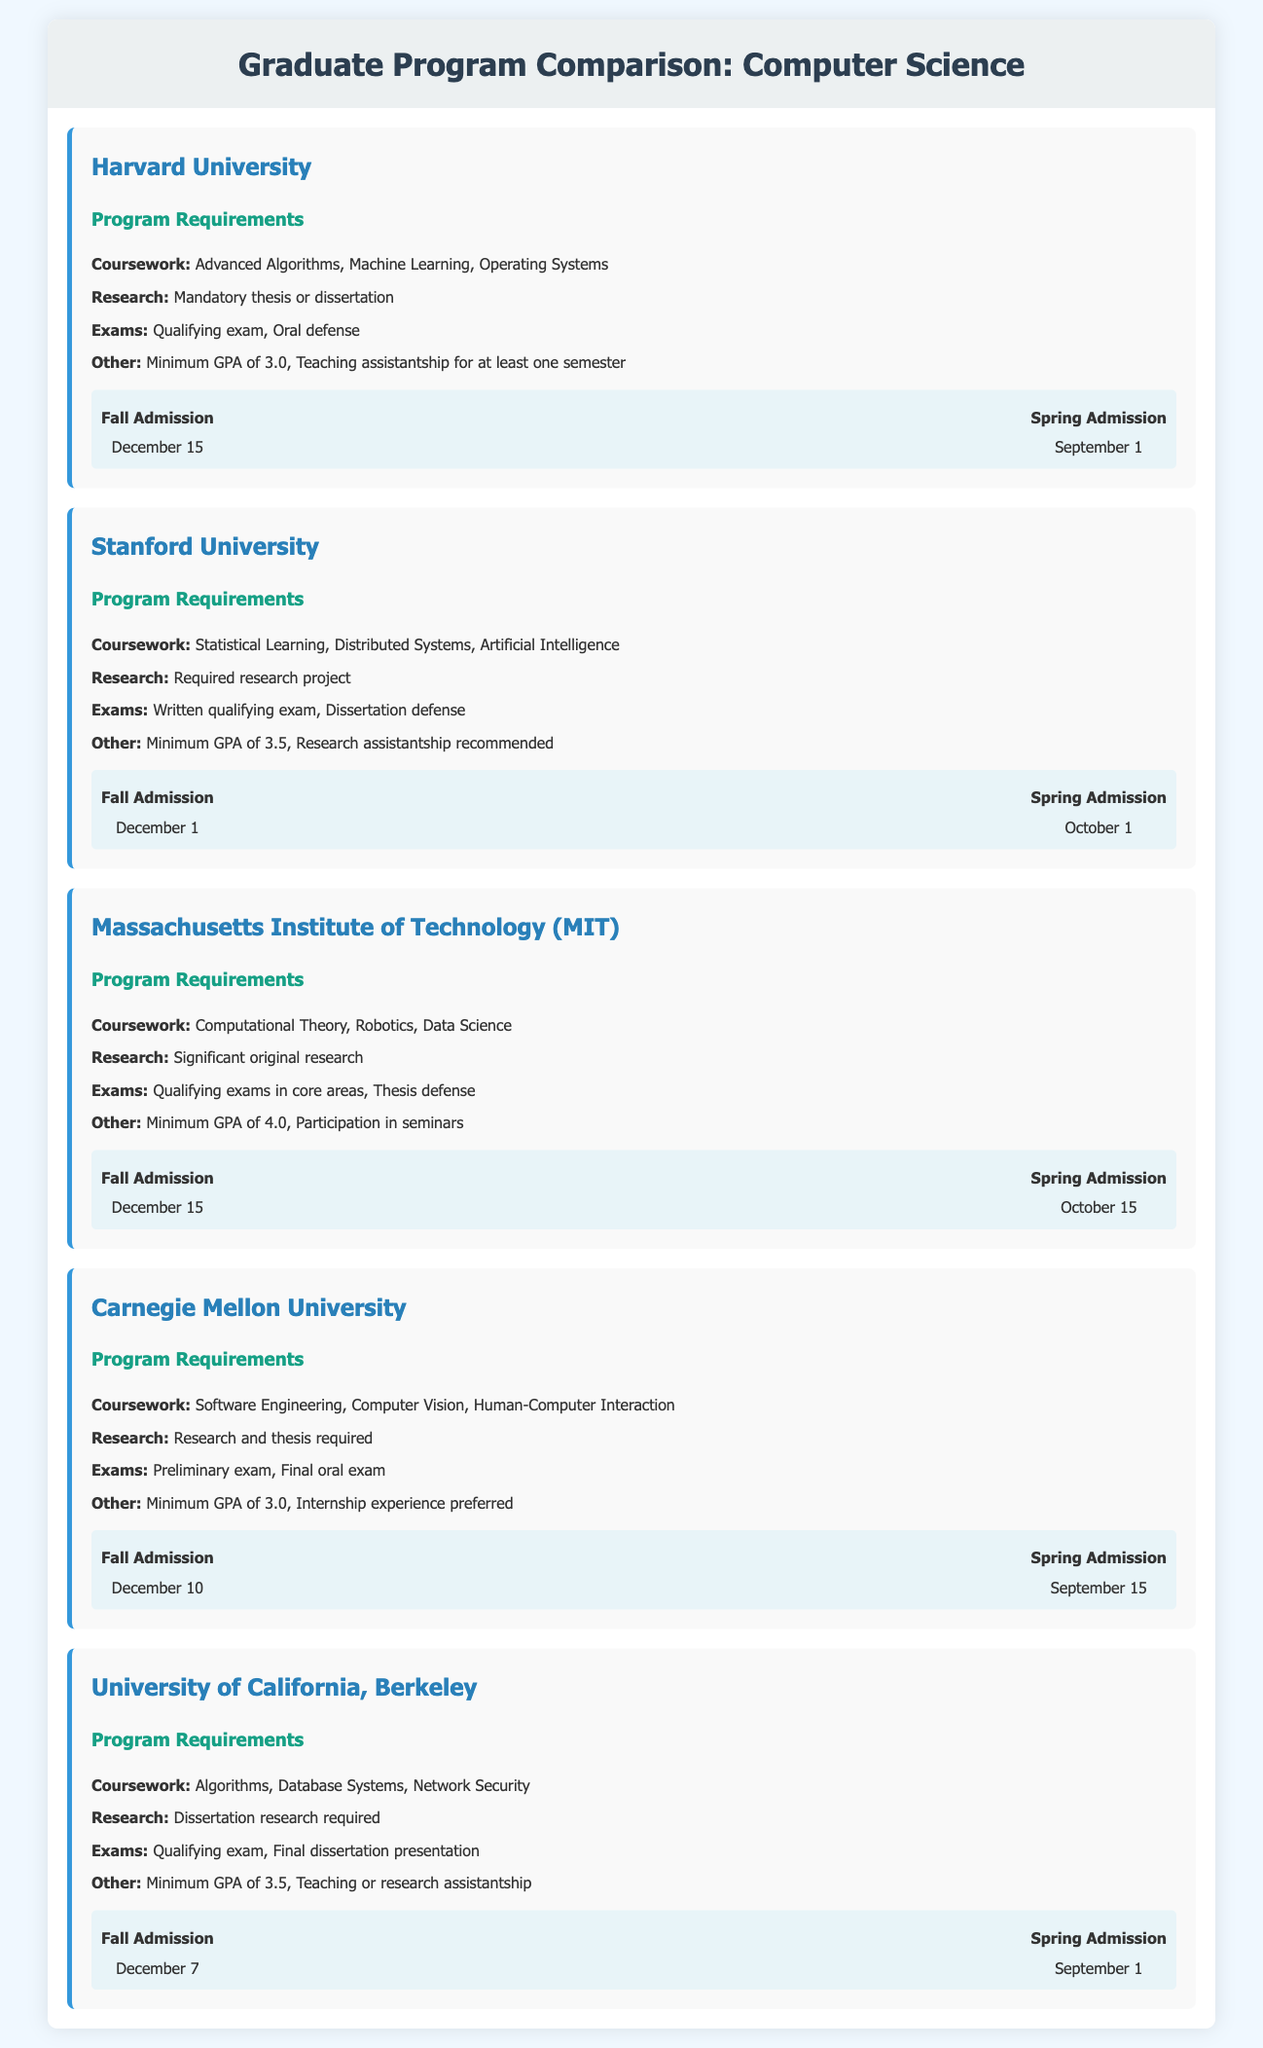What is the minimum GPA requirement for Stanford University? The minimum GPA requirement for Stanford University, as stated in the document, is 3.5.
Answer: 3.5 What is the application deadline for Fall admission at MIT? The application deadline for Fall admission at MIT is noted in the document as December 15.
Answer: December 15 Which university requires a mandatory thesis or dissertation? The university that requires a mandatory thesis or dissertation is Harvard University, as indicated in the program requirements.
Answer: Harvard University What is the recommended assistantship for Stanford University? The document mentions that a research assistantship is recommended for Stanford University, which requires a student to assist in research projects.
Answer: Research assistantship How many coursework subjects are listed for the University of California, Berkeley? The document lists four coursework subjects for the University of California, Berkeley: Algorithms, Database Systems, Network Security, and one more. The total number of subjects is four.
Answer: 4 What is the latest deadline for Spring admission across all listed universities? By checking each university's Spring admission deadlines, the latest one is found to be October 15 for MIT.
Answer: October 15 Does Carnegie Mellon University have an internship experience preference? The program requirements state that Carnegie Mellon University prefers internship experience for applicants as part of their other requirements.
Answer: Yes What type of exam is required by Massachusetts Institute of Technology? The required exam for Massachusetts Institute of Technology is the qualifying exams in core areas, along with a thesis defense mentioned in the program requirements.
Answer: Qualifying exams in core areas 